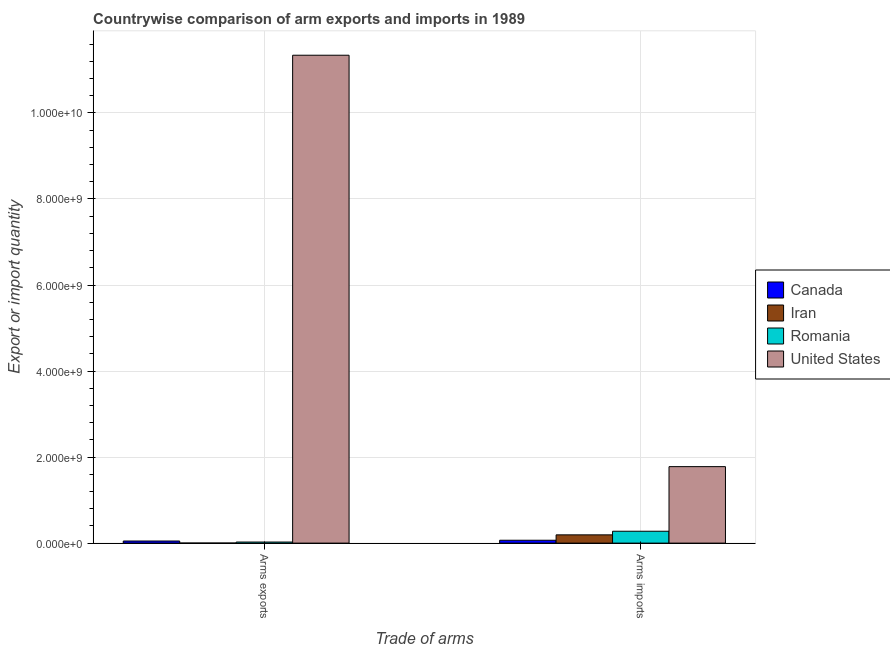Are the number of bars per tick equal to the number of legend labels?
Your answer should be compact. Yes. Are the number of bars on each tick of the X-axis equal?
Provide a succinct answer. Yes. What is the label of the 2nd group of bars from the left?
Offer a very short reply. Arms imports. What is the arms imports in United States?
Your answer should be very brief. 1.78e+09. Across all countries, what is the maximum arms exports?
Keep it short and to the point. 1.13e+1. Across all countries, what is the minimum arms imports?
Provide a short and direct response. 6.70e+07. In which country was the arms imports maximum?
Your answer should be compact. United States. In which country was the arms exports minimum?
Provide a succinct answer. Iran. What is the total arms exports in the graph?
Your answer should be compact. 1.14e+1. What is the difference between the arms exports in Canada and that in Romania?
Your answer should be very brief. 2.40e+07. What is the difference between the arms imports in Canada and the arms exports in United States?
Ensure brevity in your answer.  -1.13e+1. What is the average arms imports per country?
Offer a very short reply. 5.78e+08. What is the difference between the arms exports and arms imports in Canada?
Your answer should be compact. -1.80e+07. What is the ratio of the arms exports in Canada to that in Romania?
Offer a terse response. 1.96. Is the arms imports in Iran less than that in Romania?
Give a very brief answer. Yes. What does the 4th bar from the right in Arms imports represents?
Your response must be concise. Canada. Are all the bars in the graph horizontal?
Your answer should be very brief. No. How many countries are there in the graph?
Make the answer very short. 4. Are the values on the major ticks of Y-axis written in scientific E-notation?
Provide a short and direct response. Yes. Does the graph contain grids?
Keep it short and to the point. Yes. Where does the legend appear in the graph?
Keep it short and to the point. Center right. How are the legend labels stacked?
Offer a very short reply. Vertical. What is the title of the graph?
Give a very brief answer. Countrywise comparison of arm exports and imports in 1989. What is the label or title of the X-axis?
Provide a succinct answer. Trade of arms. What is the label or title of the Y-axis?
Give a very brief answer. Export or import quantity. What is the Export or import quantity of Canada in Arms exports?
Provide a succinct answer. 4.90e+07. What is the Export or import quantity in Romania in Arms exports?
Give a very brief answer. 2.50e+07. What is the Export or import quantity of United States in Arms exports?
Provide a short and direct response. 1.13e+1. What is the Export or import quantity of Canada in Arms imports?
Keep it short and to the point. 6.70e+07. What is the Export or import quantity in Iran in Arms imports?
Your answer should be compact. 1.92e+08. What is the Export or import quantity of Romania in Arms imports?
Make the answer very short. 2.76e+08. What is the Export or import quantity of United States in Arms imports?
Provide a succinct answer. 1.78e+09. Across all Trade of arms, what is the maximum Export or import quantity in Canada?
Make the answer very short. 6.70e+07. Across all Trade of arms, what is the maximum Export or import quantity of Iran?
Your response must be concise. 1.92e+08. Across all Trade of arms, what is the maximum Export or import quantity in Romania?
Keep it short and to the point. 2.76e+08. Across all Trade of arms, what is the maximum Export or import quantity of United States?
Give a very brief answer. 1.13e+1. Across all Trade of arms, what is the minimum Export or import quantity in Canada?
Keep it short and to the point. 4.90e+07. Across all Trade of arms, what is the minimum Export or import quantity in Romania?
Provide a succinct answer. 2.50e+07. Across all Trade of arms, what is the minimum Export or import quantity of United States?
Your response must be concise. 1.78e+09. What is the total Export or import quantity of Canada in the graph?
Give a very brief answer. 1.16e+08. What is the total Export or import quantity of Iran in the graph?
Provide a succinct answer. 1.93e+08. What is the total Export or import quantity of Romania in the graph?
Your response must be concise. 3.01e+08. What is the total Export or import quantity in United States in the graph?
Ensure brevity in your answer.  1.31e+1. What is the difference between the Export or import quantity of Canada in Arms exports and that in Arms imports?
Make the answer very short. -1.80e+07. What is the difference between the Export or import quantity of Iran in Arms exports and that in Arms imports?
Offer a terse response. -1.91e+08. What is the difference between the Export or import quantity of Romania in Arms exports and that in Arms imports?
Provide a succinct answer. -2.51e+08. What is the difference between the Export or import quantity in United States in Arms exports and that in Arms imports?
Make the answer very short. 9.56e+09. What is the difference between the Export or import quantity in Canada in Arms exports and the Export or import quantity in Iran in Arms imports?
Offer a very short reply. -1.43e+08. What is the difference between the Export or import quantity in Canada in Arms exports and the Export or import quantity in Romania in Arms imports?
Make the answer very short. -2.27e+08. What is the difference between the Export or import quantity of Canada in Arms exports and the Export or import quantity of United States in Arms imports?
Provide a succinct answer. -1.73e+09. What is the difference between the Export or import quantity in Iran in Arms exports and the Export or import quantity in Romania in Arms imports?
Provide a short and direct response. -2.75e+08. What is the difference between the Export or import quantity of Iran in Arms exports and the Export or import quantity of United States in Arms imports?
Provide a short and direct response. -1.78e+09. What is the difference between the Export or import quantity of Romania in Arms exports and the Export or import quantity of United States in Arms imports?
Make the answer very short. -1.75e+09. What is the average Export or import quantity in Canada per Trade of arms?
Your answer should be compact. 5.80e+07. What is the average Export or import quantity in Iran per Trade of arms?
Ensure brevity in your answer.  9.65e+07. What is the average Export or import quantity in Romania per Trade of arms?
Make the answer very short. 1.50e+08. What is the average Export or import quantity in United States per Trade of arms?
Your response must be concise. 6.56e+09. What is the difference between the Export or import quantity of Canada and Export or import quantity of Iran in Arms exports?
Your answer should be compact. 4.80e+07. What is the difference between the Export or import quantity of Canada and Export or import quantity of Romania in Arms exports?
Offer a very short reply. 2.40e+07. What is the difference between the Export or import quantity in Canada and Export or import quantity in United States in Arms exports?
Your response must be concise. -1.13e+1. What is the difference between the Export or import quantity of Iran and Export or import quantity of Romania in Arms exports?
Provide a succinct answer. -2.40e+07. What is the difference between the Export or import quantity in Iran and Export or import quantity in United States in Arms exports?
Keep it short and to the point. -1.13e+1. What is the difference between the Export or import quantity of Romania and Export or import quantity of United States in Arms exports?
Provide a short and direct response. -1.13e+1. What is the difference between the Export or import quantity of Canada and Export or import quantity of Iran in Arms imports?
Offer a terse response. -1.25e+08. What is the difference between the Export or import quantity in Canada and Export or import quantity in Romania in Arms imports?
Your response must be concise. -2.09e+08. What is the difference between the Export or import quantity in Canada and Export or import quantity in United States in Arms imports?
Give a very brief answer. -1.71e+09. What is the difference between the Export or import quantity of Iran and Export or import quantity of Romania in Arms imports?
Give a very brief answer. -8.40e+07. What is the difference between the Export or import quantity in Iran and Export or import quantity in United States in Arms imports?
Provide a succinct answer. -1.59e+09. What is the difference between the Export or import quantity in Romania and Export or import quantity in United States in Arms imports?
Offer a very short reply. -1.50e+09. What is the ratio of the Export or import quantity of Canada in Arms exports to that in Arms imports?
Your answer should be very brief. 0.73. What is the ratio of the Export or import quantity of Iran in Arms exports to that in Arms imports?
Your answer should be compact. 0.01. What is the ratio of the Export or import quantity of Romania in Arms exports to that in Arms imports?
Keep it short and to the point. 0.09. What is the ratio of the Export or import quantity in United States in Arms exports to that in Arms imports?
Provide a short and direct response. 6.38. What is the difference between the highest and the second highest Export or import quantity in Canada?
Ensure brevity in your answer.  1.80e+07. What is the difference between the highest and the second highest Export or import quantity of Iran?
Offer a very short reply. 1.91e+08. What is the difference between the highest and the second highest Export or import quantity of Romania?
Provide a short and direct response. 2.51e+08. What is the difference between the highest and the second highest Export or import quantity of United States?
Ensure brevity in your answer.  9.56e+09. What is the difference between the highest and the lowest Export or import quantity in Canada?
Make the answer very short. 1.80e+07. What is the difference between the highest and the lowest Export or import quantity of Iran?
Offer a very short reply. 1.91e+08. What is the difference between the highest and the lowest Export or import quantity in Romania?
Give a very brief answer. 2.51e+08. What is the difference between the highest and the lowest Export or import quantity of United States?
Provide a succinct answer. 9.56e+09. 